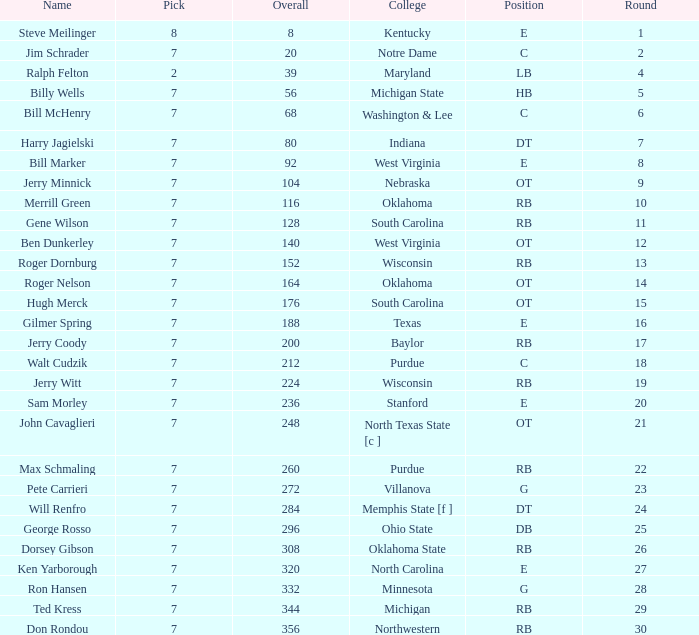What is the number of the round in which Ron Hansen was drafted and the overall is greater than 332? 0.0. 